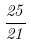Convert formula to latex. <formula><loc_0><loc_0><loc_500><loc_500>\frac { 2 5 } { 2 1 }</formula> 